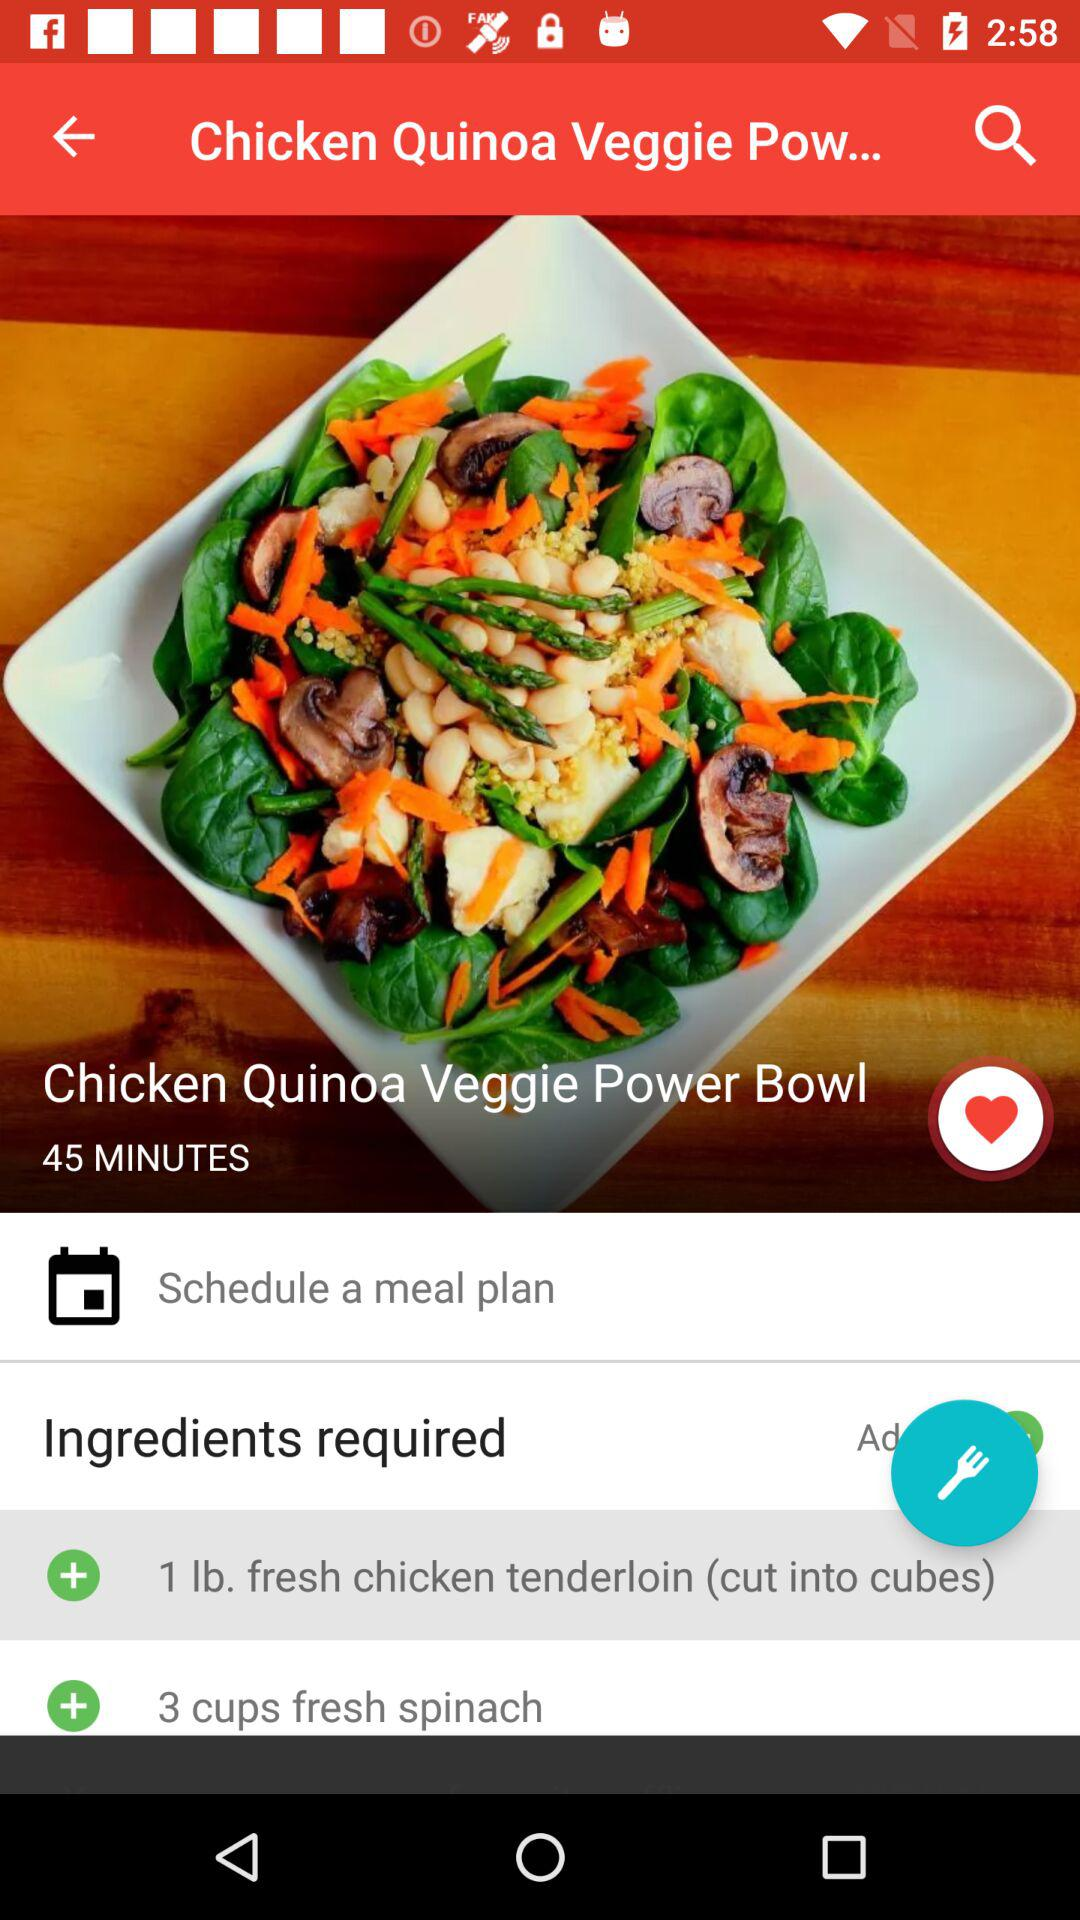How many cups of spinach are needed for this recipe?
Answer the question using a single word or phrase. 3 